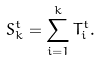Convert formula to latex. <formula><loc_0><loc_0><loc_500><loc_500>S _ { k } ^ { t } = \sum _ { i = 1 } ^ { k } T _ { i } ^ { t } .</formula> 